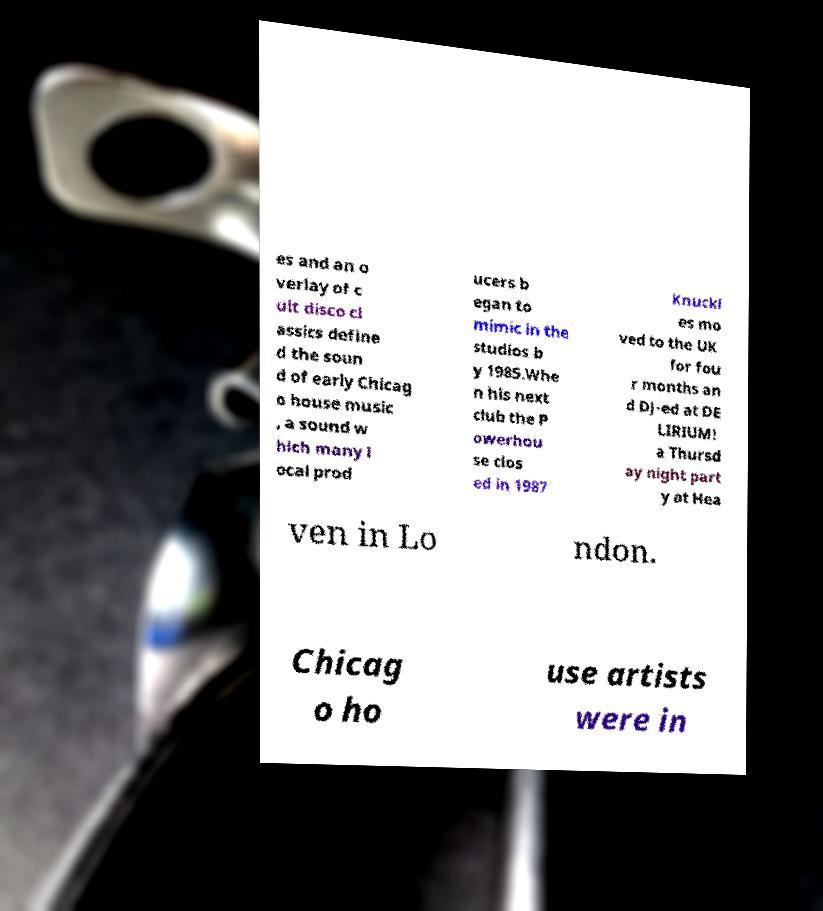What messages or text are displayed in this image? I need them in a readable, typed format. es and an o verlay of c ult disco cl assics define d the soun d of early Chicag o house music , a sound w hich many l ocal prod ucers b egan to mimic in the studios b y 1985.Whe n his next club the P owerhou se clos ed in 1987 Knuckl es mo ved to the UK for fou r months an d DJ-ed at DE LIRIUM! a Thursd ay night part y at Hea ven in Lo ndon. Chicag o ho use artists were in 